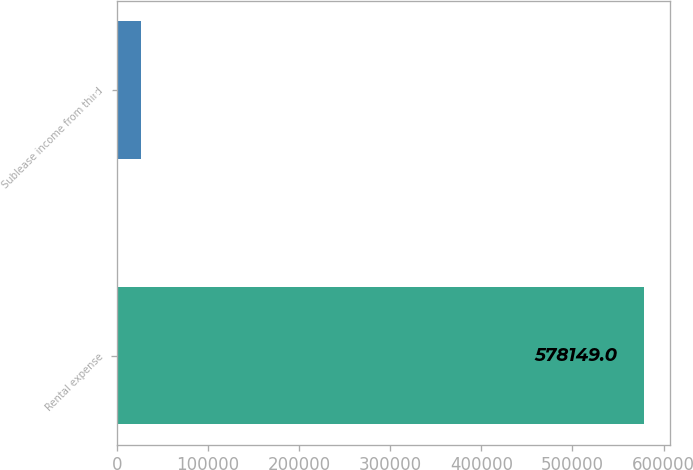<chart> <loc_0><loc_0><loc_500><loc_500><bar_chart><fcel>Rental expense<fcel>Sublease income from third<nl><fcel>578149<fcel>26403<nl></chart> 